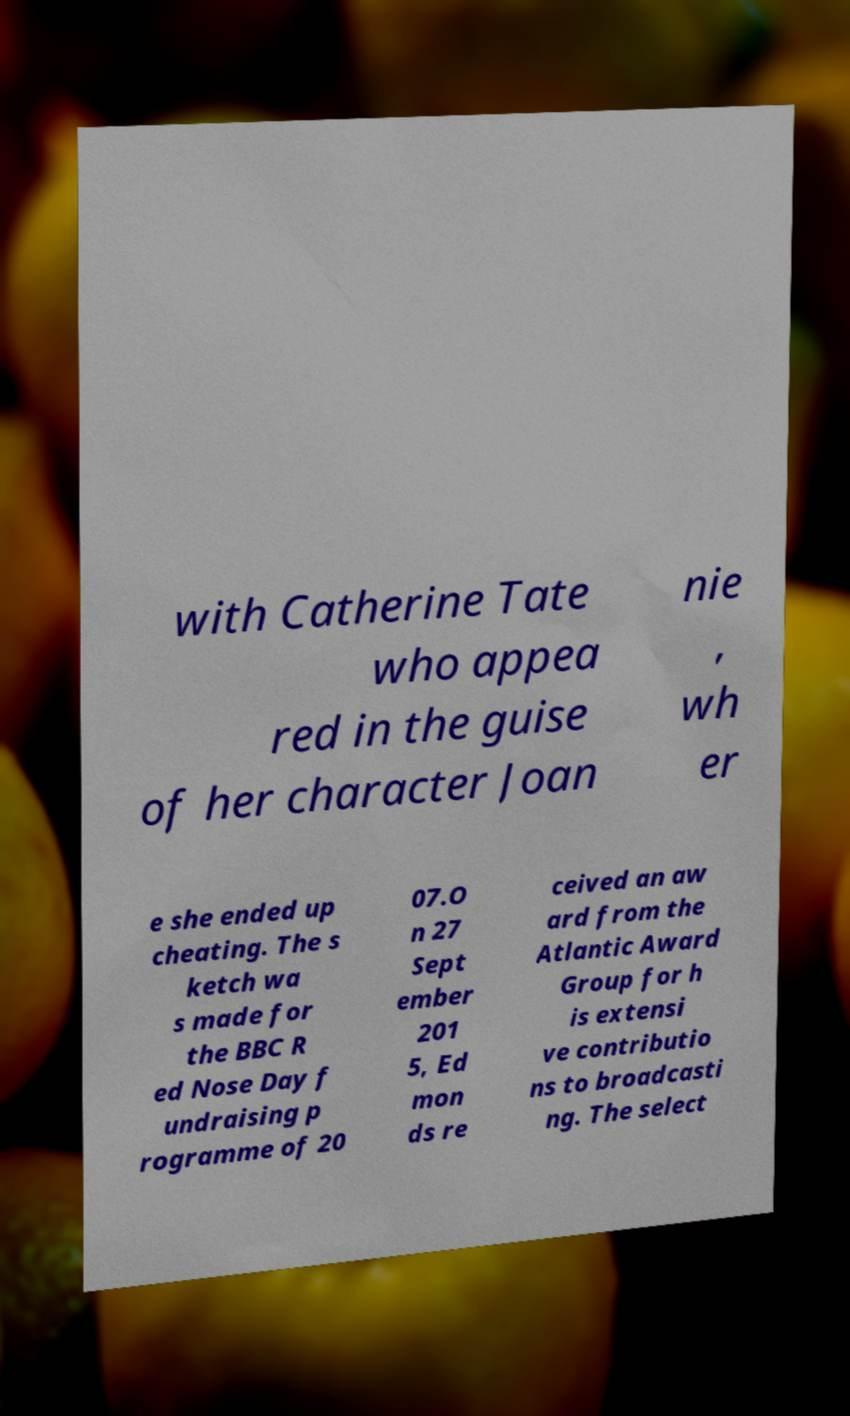Could you extract and type out the text from this image? with Catherine Tate who appea red in the guise of her character Joan nie , wh er e she ended up cheating. The s ketch wa s made for the BBC R ed Nose Day f undraising p rogramme of 20 07.O n 27 Sept ember 201 5, Ed mon ds re ceived an aw ard from the Atlantic Award Group for h is extensi ve contributio ns to broadcasti ng. The select 